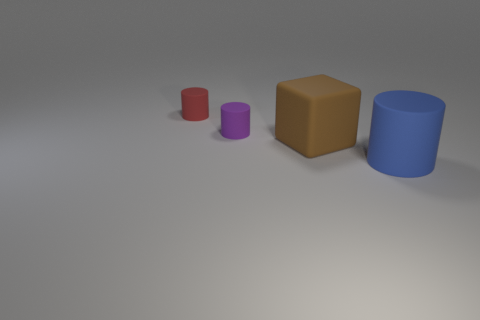There is a matte cylinder in front of the brown object; does it have the same size as the tiny purple cylinder?
Provide a short and direct response. No. What number of brown objects are tiny rubber things or cubes?
Ensure brevity in your answer.  1. There is a cylinder that is behind the purple matte cylinder; what material is it?
Ensure brevity in your answer.  Rubber. What number of rubber blocks are right of the big rubber thing that is to the right of the big brown thing?
Your answer should be very brief. 0. What number of small purple matte things have the same shape as the brown thing?
Keep it short and to the point. 0. How many small matte things are there?
Offer a very short reply. 2. The cylinder on the right side of the brown rubber cube is what color?
Your answer should be compact. Blue. What is the color of the matte thing to the right of the big thing behind the blue rubber object?
Provide a succinct answer. Blue. There is a matte cylinder that is the same size as the red thing; what color is it?
Your answer should be compact. Purple. How many rubber cylinders are both on the right side of the tiny red rubber thing and behind the large cylinder?
Keep it short and to the point. 1. 